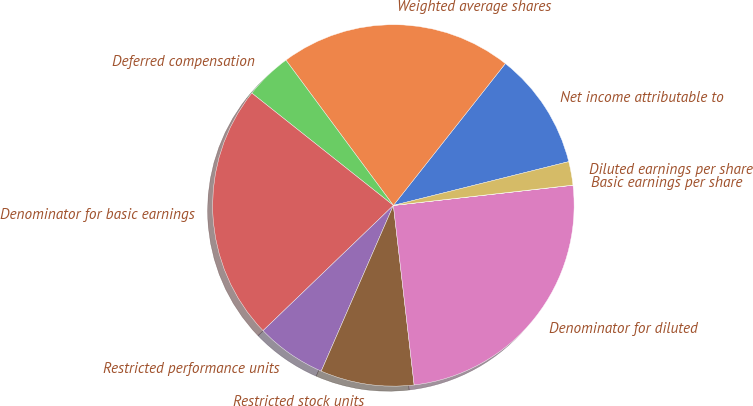Convert chart to OTSL. <chart><loc_0><loc_0><loc_500><loc_500><pie_chart><fcel>Net income attributable to<fcel>Weighted average shares<fcel>Deferred compensation<fcel>Denominator for basic earnings<fcel>Restricted performance units<fcel>Restricted stock units<fcel>Denominator for diluted<fcel>Basic earnings per share<fcel>Diluted earnings per share<nl><fcel>10.47%<fcel>20.77%<fcel>4.19%<fcel>22.86%<fcel>6.28%<fcel>8.37%<fcel>24.95%<fcel>0.01%<fcel>2.1%<nl></chart> 